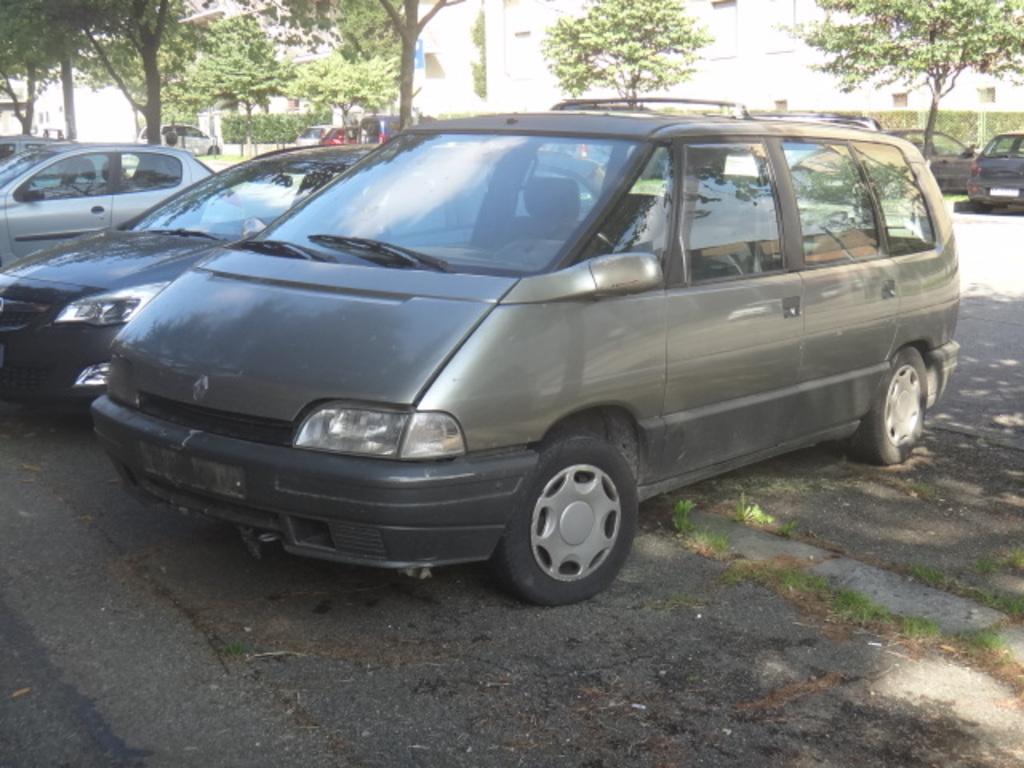Could you give a brief overview of what you see in this image? In this image we can see a group of cars parked on the ground. We can also see some grass, a board, a group of trees, plants, a fence and some buildings. 